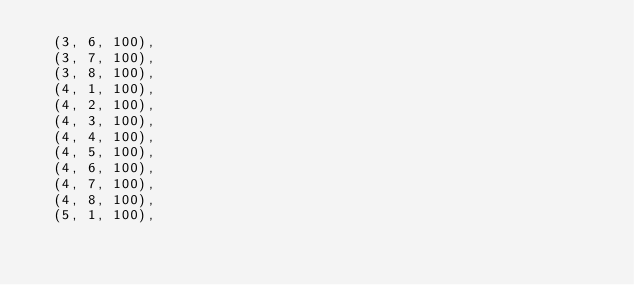<code> <loc_0><loc_0><loc_500><loc_500><_SQL_>	(3, 6, 100),
	(3, 7, 100),
	(3, 8, 100),
	(4, 1, 100),
	(4, 2, 100),
	(4, 3, 100),
	(4, 4, 100),
	(4, 5, 100),
	(4, 6, 100),
	(4, 7, 100),
	(4, 8, 100),
	(5, 1, 100),</code> 